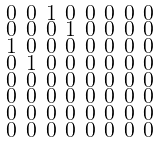<formula> <loc_0><loc_0><loc_500><loc_500>\begin{smallmatrix} 0 & 0 & 1 & 0 & 0 & 0 & 0 & 0 \\ 0 & 0 & 0 & 1 & 0 & 0 & 0 & 0 \\ 1 & 0 & 0 & 0 & 0 & 0 & 0 & 0 \\ 0 & 1 & 0 & 0 & 0 & 0 & 0 & 0 \\ 0 & 0 & 0 & 0 & 0 & 0 & 0 & 0 \\ 0 & 0 & 0 & 0 & 0 & 0 & 0 & 0 \\ 0 & 0 & 0 & 0 & 0 & 0 & 0 & 0 \\ 0 & 0 & 0 & 0 & 0 & 0 & 0 & 0 \end{smallmatrix}</formula> 